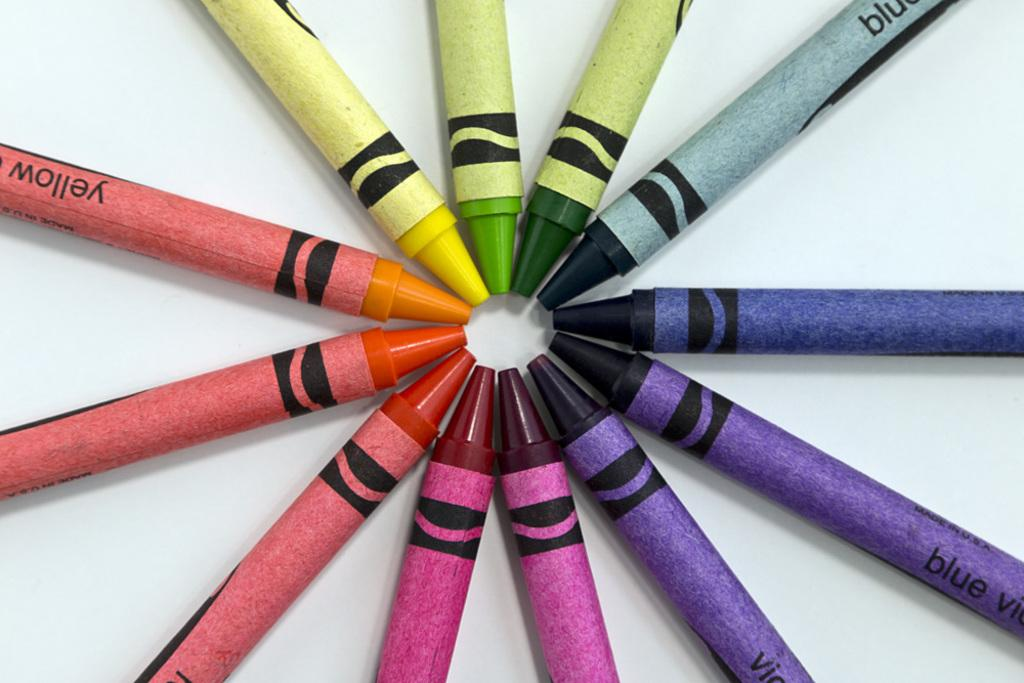Provide a one-sentence caption for the provided image. A series of crayons pointed toward each other in a circle including yellow and blue. 